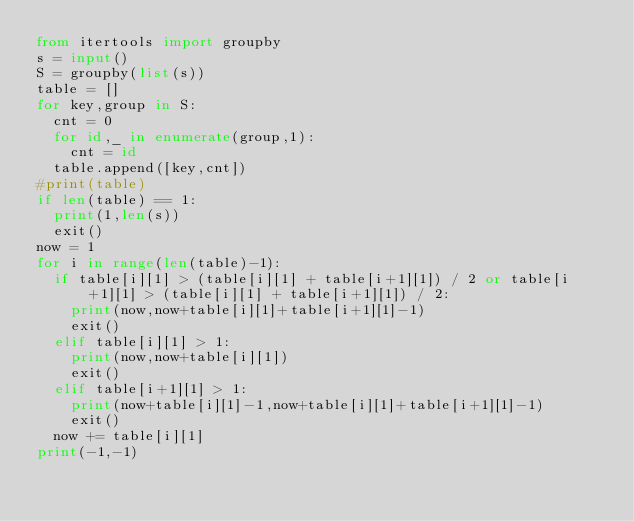Convert code to text. <code><loc_0><loc_0><loc_500><loc_500><_Python_>from itertools import groupby
s = input()
S = groupby(list(s))
table = []
for key,group in S:
  cnt = 0
  for id,_ in enumerate(group,1):
    cnt = id
  table.append([key,cnt])
#print(table)
if len(table) == 1:
  print(1,len(s))
  exit()
now = 1
for i in range(len(table)-1):
  if table[i][1] > (table[i][1] + table[i+1][1]) / 2 or table[i+1][1] > (table[i][1] + table[i+1][1]) / 2:
    print(now,now+table[i][1]+table[i+1][1]-1)
    exit()
  elif table[i][1] > 1:
    print(now,now+table[i][1])
    exit()
  elif table[i+1][1] > 1:
    print(now+table[i][1]-1,now+table[i][1]+table[i+1][1]-1)
    exit()
  now += table[i][1]
print(-1,-1)
    
  </code> 